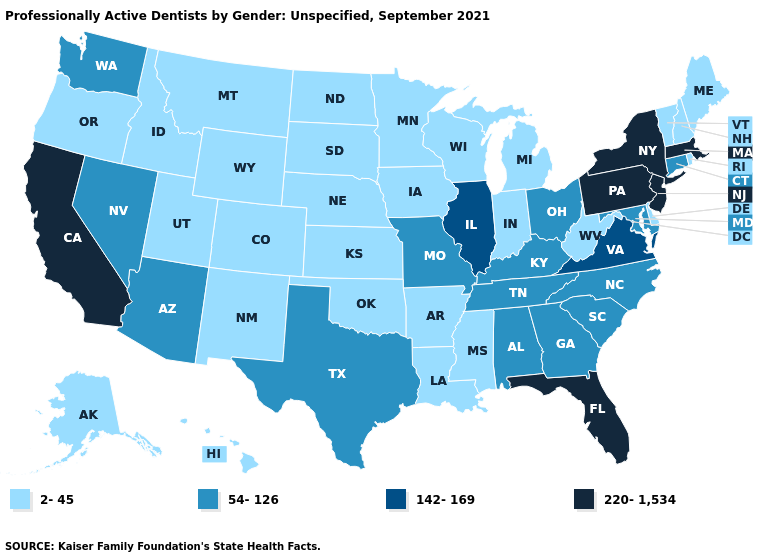Name the states that have a value in the range 220-1,534?
Quick response, please. California, Florida, Massachusetts, New Jersey, New York, Pennsylvania. What is the value of Maryland?
Give a very brief answer. 54-126. What is the value of Arizona?
Quick response, please. 54-126. Name the states that have a value in the range 2-45?
Quick response, please. Alaska, Arkansas, Colorado, Delaware, Hawaii, Idaho, Indiana, Iowa, Kansas, Louisiana, Maine, Michigan, Minnesota, Mississippi, Montana, Nebraska, New Hampshire, New Mexico, North Dakota, Oklahoma, Oregon, Rhode Island, South Dakota, Utah, Vermont, West Virginia, Wisconsin, Wyoming. What is the lowest value in states that border Maryland?
Write a very short answer. 2-45. What is the value of Ohio?
Short answer required. 54-126. What is the value of Florida?
Give a very brief answer. 220-1,534. Name the states that have a value in the range 54-126?
Write a very short answer. Alabama, Arizona, Connecticut, Georgia, Kentucky, Maryland, Missouri, Nevada, North Carolina, Ohio, South Carolina, Tennessee, Texas, Washington. What is the value of Maryland?
Concise answer only. 54-126. Name the states that have a value in the range 54-126?
Be succinct. Alabama, Arizona, Connecticut, Georgia, Kentucky, Maryland, Missouri, Nevada, North Carolina, Ohio, South Carolina, Tennessee, Texas, Washington. Among the states that border Texas , which have the lowest value?
Quick response, please. Arkansas, Louisiana, New Mexico, Oklahoma. What is the lowest value in states that border Georgia?
Be succinct. 54-126. Does New York have the highest value in the USA?
Write a very short answer. Yes. Does Rhode Island have the lowest value in the Northeast?
Be succinct. Yes. 